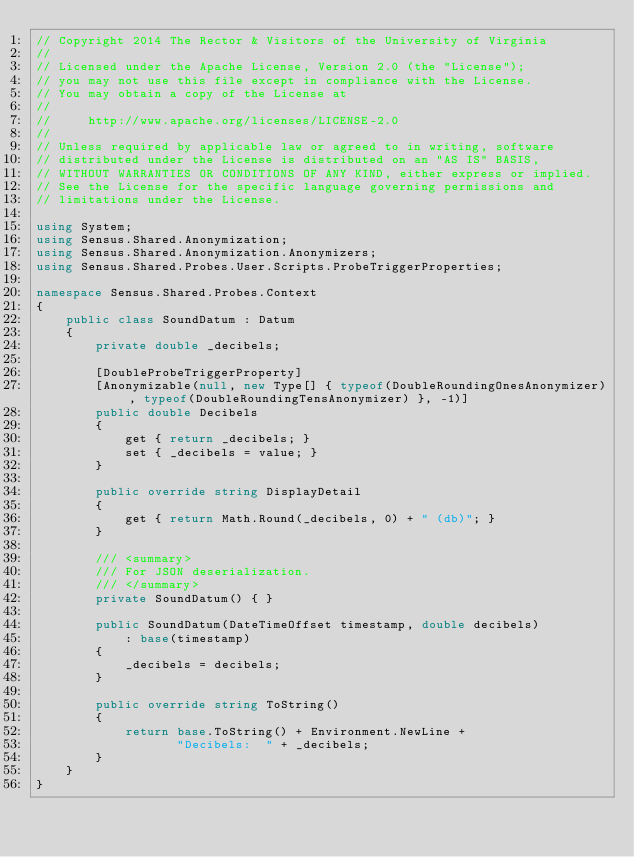<code> <loc_0><loc_0><loc_500><loc_500><_C#_>// Copyright 2014 The Rector & Visitors of the University of Virginia
//
// Licensed under the Apache License, Version 2.0 (the "License");
// you may not use this file except in compliance with the License.
// You may obtain a copy of the License at
//
//     http://www.apache.org/licenses/LICENSE-2.0
//
// Unless required by applicable law or agreed to in writing, software
// distributed under the License is distributed on an "AS IS" BASIS,
// WITHOUT WARRANTIES OR CONDITIONS OF ANY KIND, either express or implied.
// See the License for the specific language governing permissions and
// limitations under the License.

using System;
using Sensus.Shared.Anonymization;
using Sensus.Shared.Anonymization.Anonymizers;
using Sensus.Shared.Probes.User.Scripts.ProbeTriggerProperties;

namespace Sensus.Shared.Probes.Context
{
    public class SoundDatum : Datum
    {
        private double _decibels;

        [DoubleProbeTriggerProperty]
        [Anonymizable(null, new Type[] { typeof(DoubleRoundingOnesAnonymizer), typeof(DoubleRoundingTensAnonymizer) }, -1)]
        public double Decibels
        {
            get { return _decibels; }
            set { _decibels = value; }
        }

        public override string DisplayDetail
        {
            get { return Math.Round(_decibels, 0) + " (db)"; }
        }

        /// <summary>
        /// For JSON deserialization.
        /// </summary>
        private SoundDatum() { }

        public SoundDatum(DateTimeOffset timestamp, double decibels)
            : base(timestamp)
        {
            _decibels = decibels;
        }

        public override string ToString()
        {
            return base.ToString() + Environment.NewLine +
                   "Decibels:  " + _decibels;
        }
    }
}
</code> 